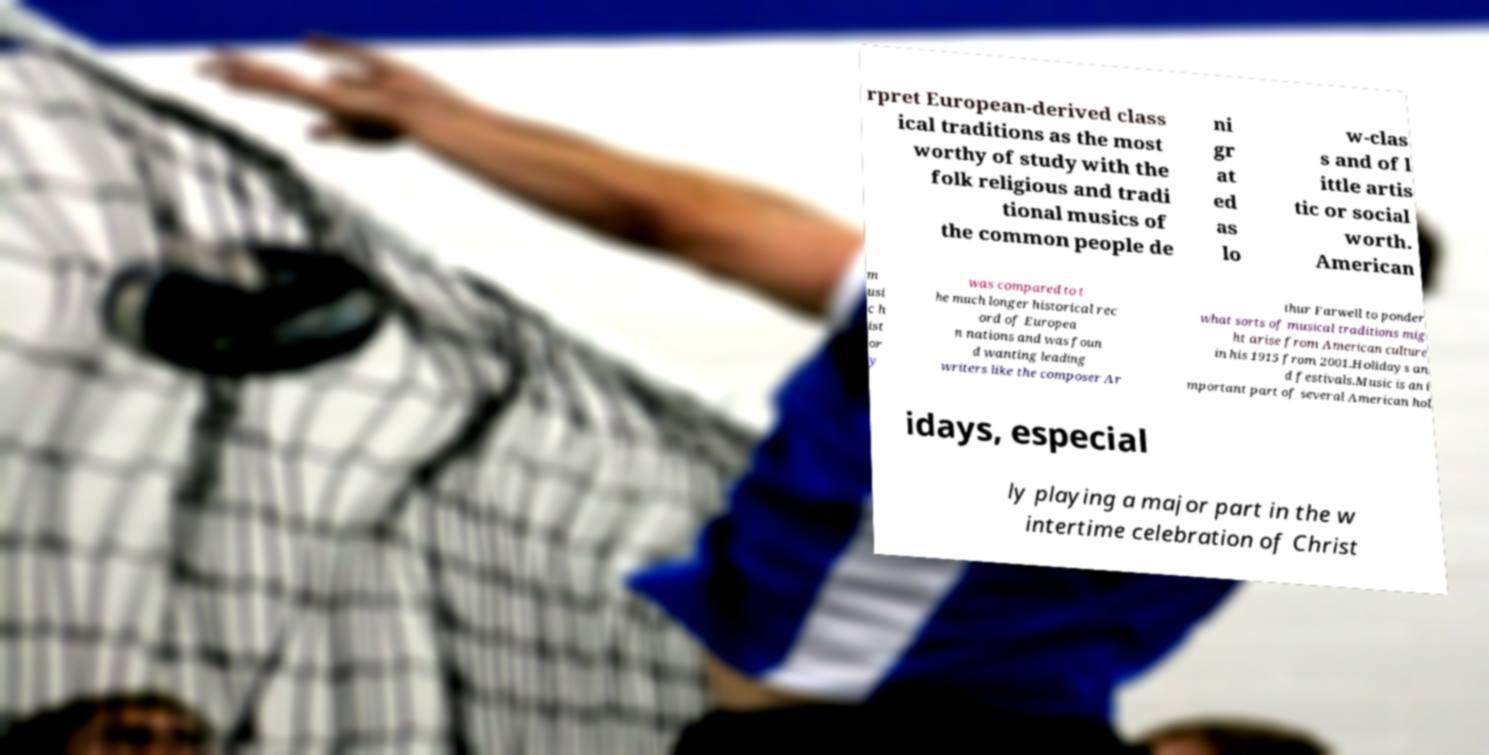Please read and relay the text visible in this image. What does it say? rpret European-derived class ical traditions as the most worthy of study with the folk religious and tradi tional musics of the common people de ni gr at ed as lo w-clas s and of l ittle artis tic or social worth. American m usi c h ist or y was compared to t he much longer historical rec ord of Europea n nations and was foun d wanting leading writers like the composer Ar thur Farwell to ponder what sorts of musical traditions mig ht arise from American culture in his 1915 from 2001.Holidays an d festivals.Music is an i mportant part of several American hol idays, especial ly playing a major part in the w intertime celebration of Christ 